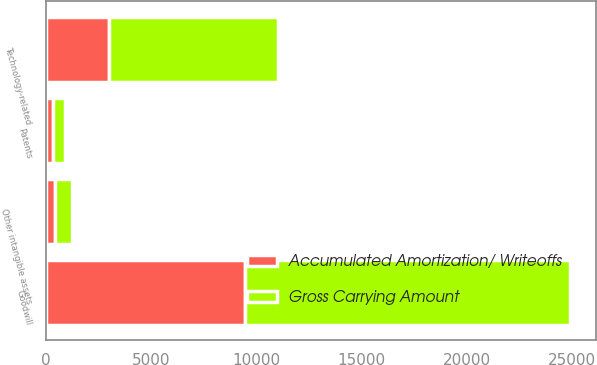Convert chart. <chart><loc_0><loc_0><loc_500><loc_500><stacked_bar_chart><ecel><fcel>Technology-related<fcel>Patents<fcel>Other intangible assets<fcel>Goodwill<nl><fcel>Gross Carrying Amount<fcel>8020<fcel>559<fcel>810<fcel>15450<nl><fcel>Accumulated Amortization/ Writeoffs<fcel>3005<fcel>352<fcel>428<fcel>9477<nl></chart> 